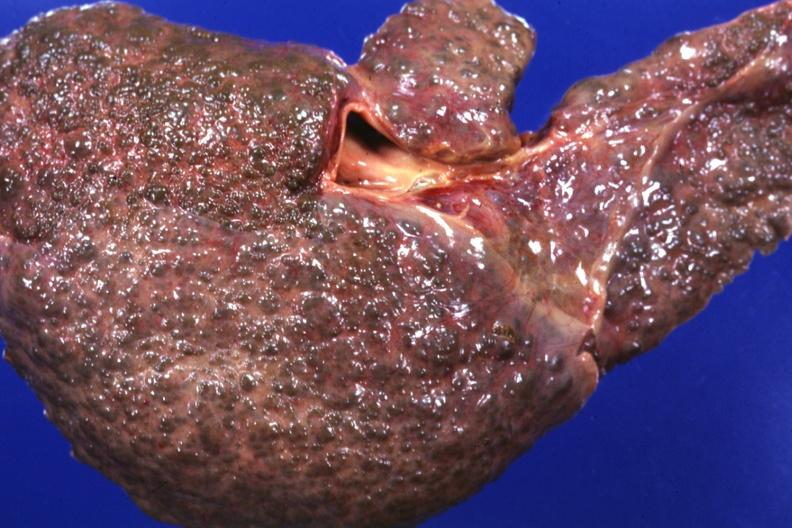what is present?
Answer the question using a single word or phrase. Liver 